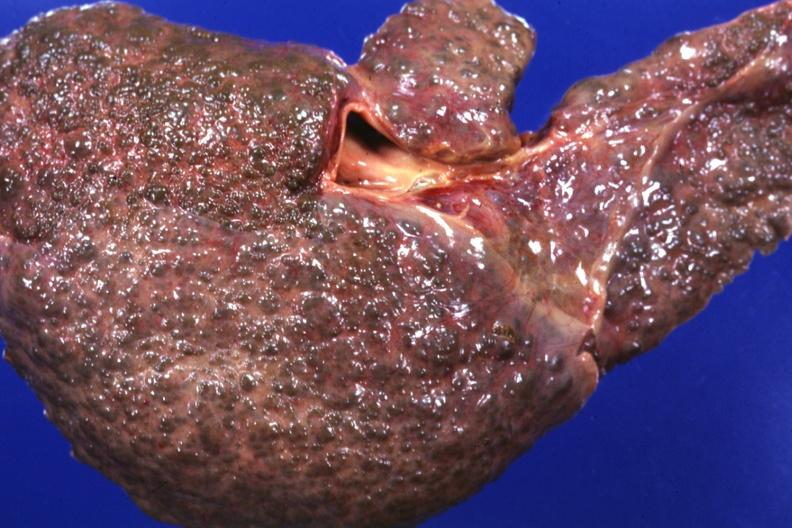what is present?
Answer the question using a single word or phrase. Liver 